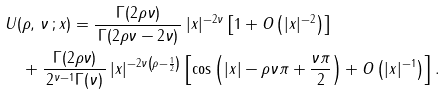<formula> <loc_0><loc_0><loc_500><loc_500>& U ( \rho , \, \nu \, ; x ) = \frac { \Gamma ( 2 \rho \nu ) } { \, \Gamma ( 2 \rho \nu - 2 \nu ) \, } \, | x | ^ { - 2 \nu } \left [ 1 + O \left ( | x | ^ { - 2 } \right ) \right ] \\ & \quad + \frac { \Gamma ( 2 \rho \nu ) } { \, 2 ^ { \nu - 1 } \Gamma ( \nu ) \, } \, | x | ^ { - 2 \nu \left ( \rho - \frac { 1 } { 2 } \right ) } \left [ \cos \left ( | x | - \rho \nu \pi + \frac { \nu \pi } { 2 } \right ) + O \left ( | x | ^ { - 1 } \right ) \right ] .</formula> 